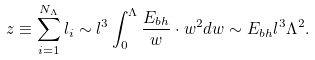<formula> <loc_0><loc_0><loc_500><loc_500>z \equiv \sum _ { i = 1 } ^ { N _ { \Lambda } } l _ { i } \sim l ^ { 3 } \int _ { 0 } ^ { \Lambda } \frac { E _ { b h } } { w } \cdot w ^ { 2 } d w \sim E _ { b h } l ^ { 3 } \Lambda ^ { 2 } .</formula> 